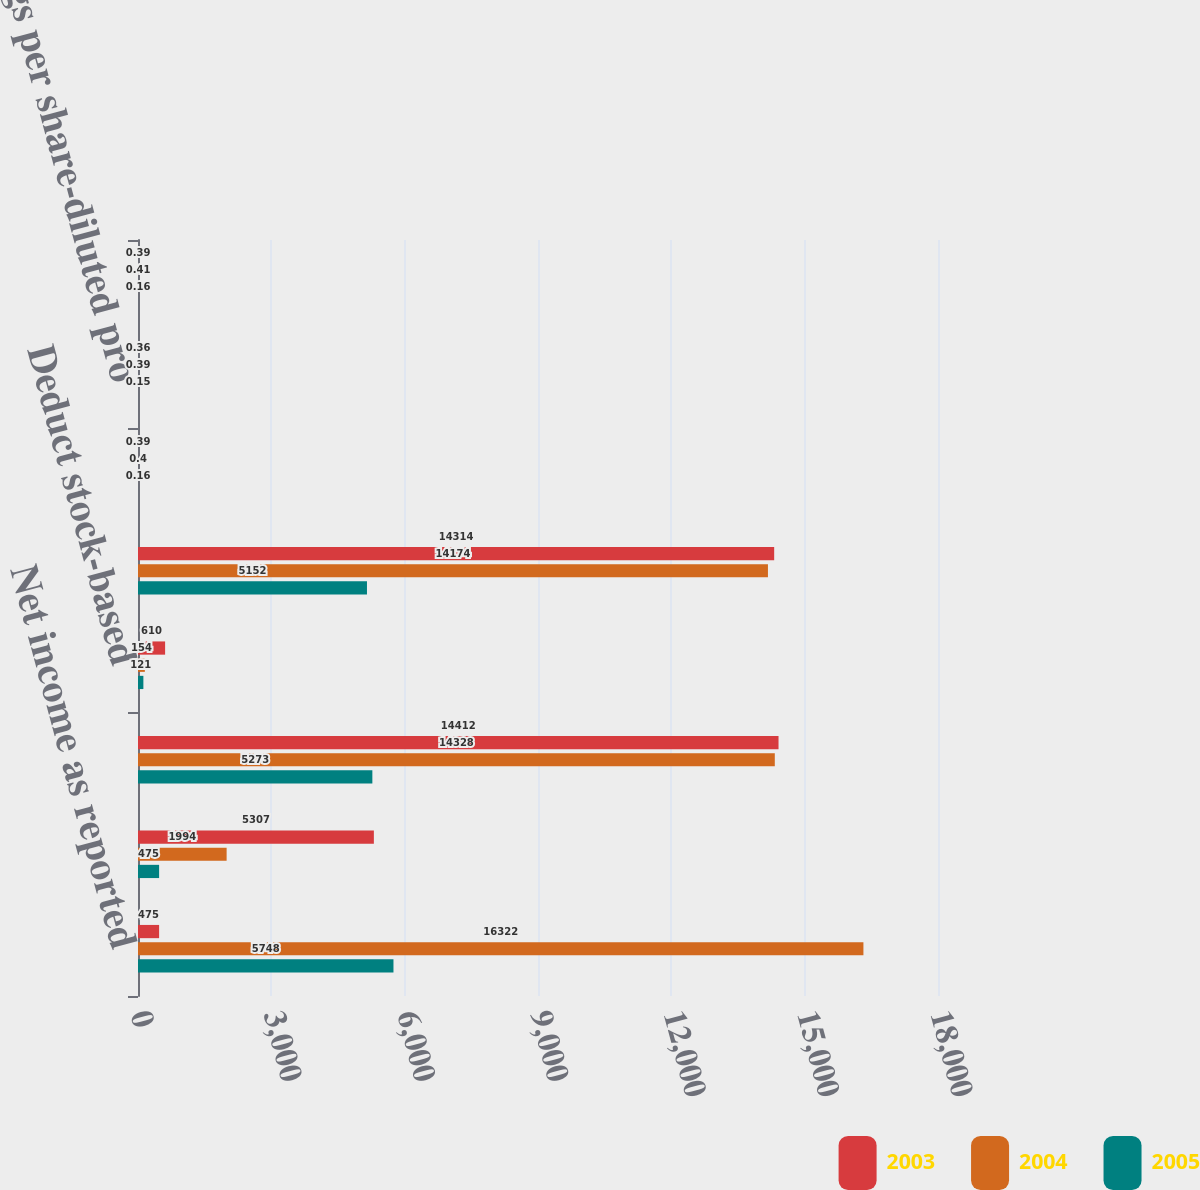<chart> <loc_0><loc_0><loc_500><loc_500><stacked_bar_chart><ecel><fcel>Net income as reported<fcel>Accretion of and cumulative<fcel>Net income available to common<fcel>Deduct stock-based<fcel>Pro forma net income<fcel>Earnings per share-basic pro<fcel>Earnings per share-diluted pro<fcel>Earnings per share-basic as<nl><fcel>2003<fcel>475<fcel>5307<fcel>14412<fcel>610<fcel>14314<fcel>0.39<fcel>0.36<fcel>0.39<nl><fcel>2004<fcel>16322<fcel>1994<fcel>14328<fcel>154<fcel>14174<fcel>0.4<fcel>0.39<fcel>0.41<nl><fcel>2005<fcel>5748<fcel>475<fcel>5273<fcel>121<fcel>5152<fcel>0.16<fcel>0.15<fcel>0.16<nl></chart> 